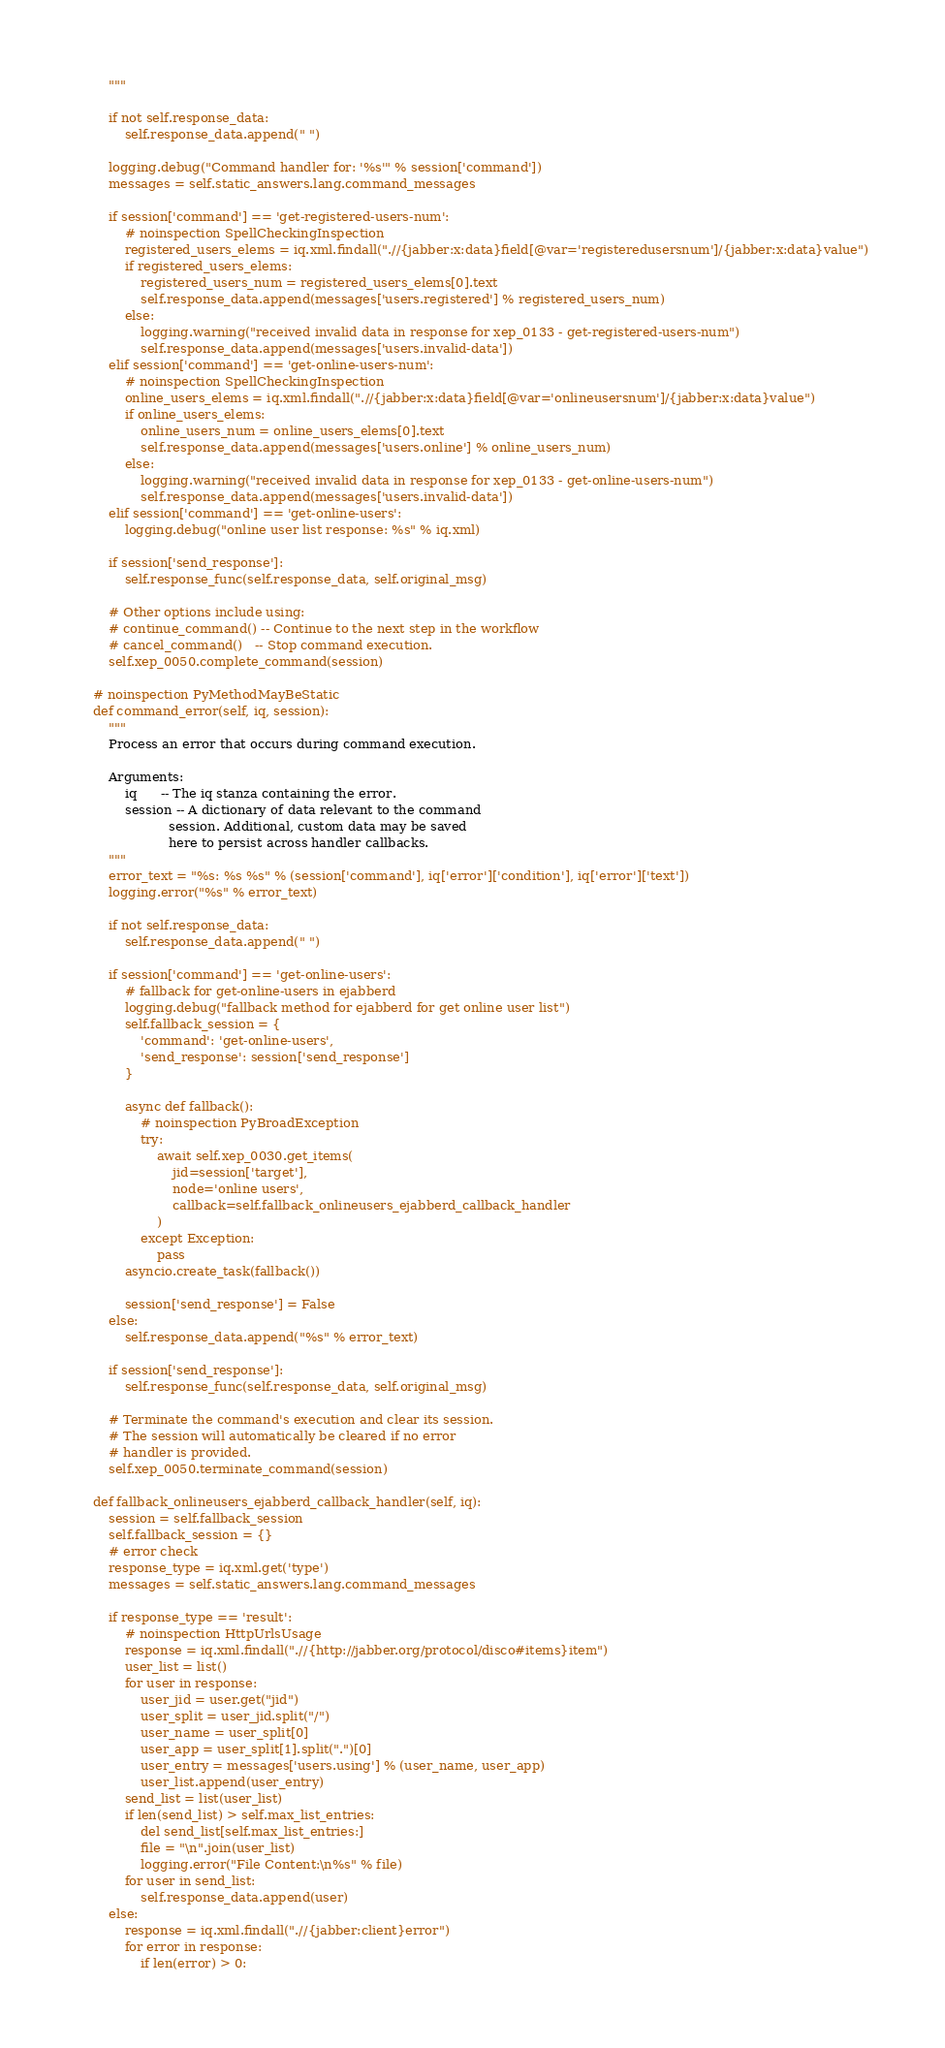<code> <loc_0><loc_0><loc_500><loc_500><_Python_>        """

        if not self.response_data:
            self.response_data.append(" ")

        logging.debug("Command handler for: '%s'" % session['command'])
        messages = self.static_answers.lang.command_messages

        if session['command'] == 'get-registered-users-num':
            # noinspection SpellCheckingInspection
            registered_users_elems = iq.xml.findall(".//{jabber:x:data}field[@var='registeredusersnum']/{jabber:x:data}value")
            if registered_users_elems:
                registered_users_num = registered_users_elems[0].text
                self.response_data.append(messages['users.registered'] % registered_users_num)
            else:
                logging.warning("received invalid data in response for xep_0133 - get-registered-users-num")
                self.response_data.append(messages['users.invalid-data'])
        elif session['command'] == 'get-online-users-num':
            # noinspection SpellCheckingInspection
            online_users_elems = iq.xml.findall(".//{jabber:x:data}field[@var='onlineusersnum']/{jabber:x:data}value")
            if online_users_elems:
                online_users_num = online_users_elems[0].text
                self.response_data.append(messages['users.online'] % online_users_num)
            else:
                logging.warning("received invalid data in response for xep_0133 - get-online-users-num")
                self.response_data.append(messages['users.invalid-data'])
        elif session['command'] == 'get-online-users':
            logging.debug("online user list response: %s" % iq.xml)

        if session['send_response']:
            self.response_func(self.response_data, self.original_msg)

        # Other options include using:
        # continue_command() -- Continue to the next step in the workflow
        # cancel_command()   -- Stop command execution.
        self.xep_0050.complete_command(session)

    # noinspection PyMethodMayBeStatic
    def command_error(self, iq, session):
        """
        Process an error that occurs during command execution.

        Arguments:
            iq      -- The iq stanza containing the error.
            session -- A dictionary of data relevant to the command
                       session. Additional, custom data may be saved
                       here to persist across handler callbacks.
        """
        error_text = "%s: %s %s" % (session['command'], iq['error']['condition'], iq['error']['text'])
        logging.error("%s" % error_text)

        if not self.response_data:
            self.response_data.append(" ")

        if session['command'] == 'get-online-users':
            # fallback for get-online-users in ejabberd
            logging.debug("fallback method for ejabberd for get online user list")
            self.fallback_session = {
                'command': 'get-online-users',
                'send_response': session['send_response']
            }

            async def fallback():
                # noinspection PyBroadException
                try:
                    await self.xep_0030.get_items(
                        jid=session['target'],
                        node='online users',
                        callback=self.fallback_onlineusers_ejabberd_callback_handler
                    )
                except Exception:
                    pass
            asyncio.create_task(fallback())

            session['send_response'] = False
        else:
            self.response_data.append("%s" % error_text)

        if session['send_response']:
            self.response_func(self.response_data, self.original_msg)

        # Terminate the command's execution and clear its session.
        # The session will automatically be cleared if no error
        # handler is provided.
        self.xep_0050.terminate_command(session)

    def fallback_onlineusers_ejabberd_callback_handler(self, iq):
        session = self.fallback_session
        self.fallback_session = {}
        # error check
        response_type = iq.xml.get('type')
        messages = self.static_answers.lang.command_messages

        if response_type == 'result':
            # noinspection HttpUrlsUsage
            response = iq.xml.findall(".//{http://jabber.org/protocol/disco#items}item")
            user_list = list()
            for user in response:
                user_jid = user.get("jid")
                user_split = user_jid.split("/")
                user_name = user_split[0]
                user_app = user_split[1].split(".")[0]
                user_entry = messages['users.using'] % (user_name, user_app)
                user_list.append(user_entry)
            send_list = list(user_list)
            if len(send_list) > self.max_list_entries:
                del send_list[self.max_list_entries:]
                file = "\n".join(user_list)
                logging.error("File Content:\n%s" % file)
            for user in send_list:
                self.response_data.append(user)
        else:
            response = iq.xml.findall(".//{jabber:client}error")
            for error in response:
                if len(error) > 0:</code> 